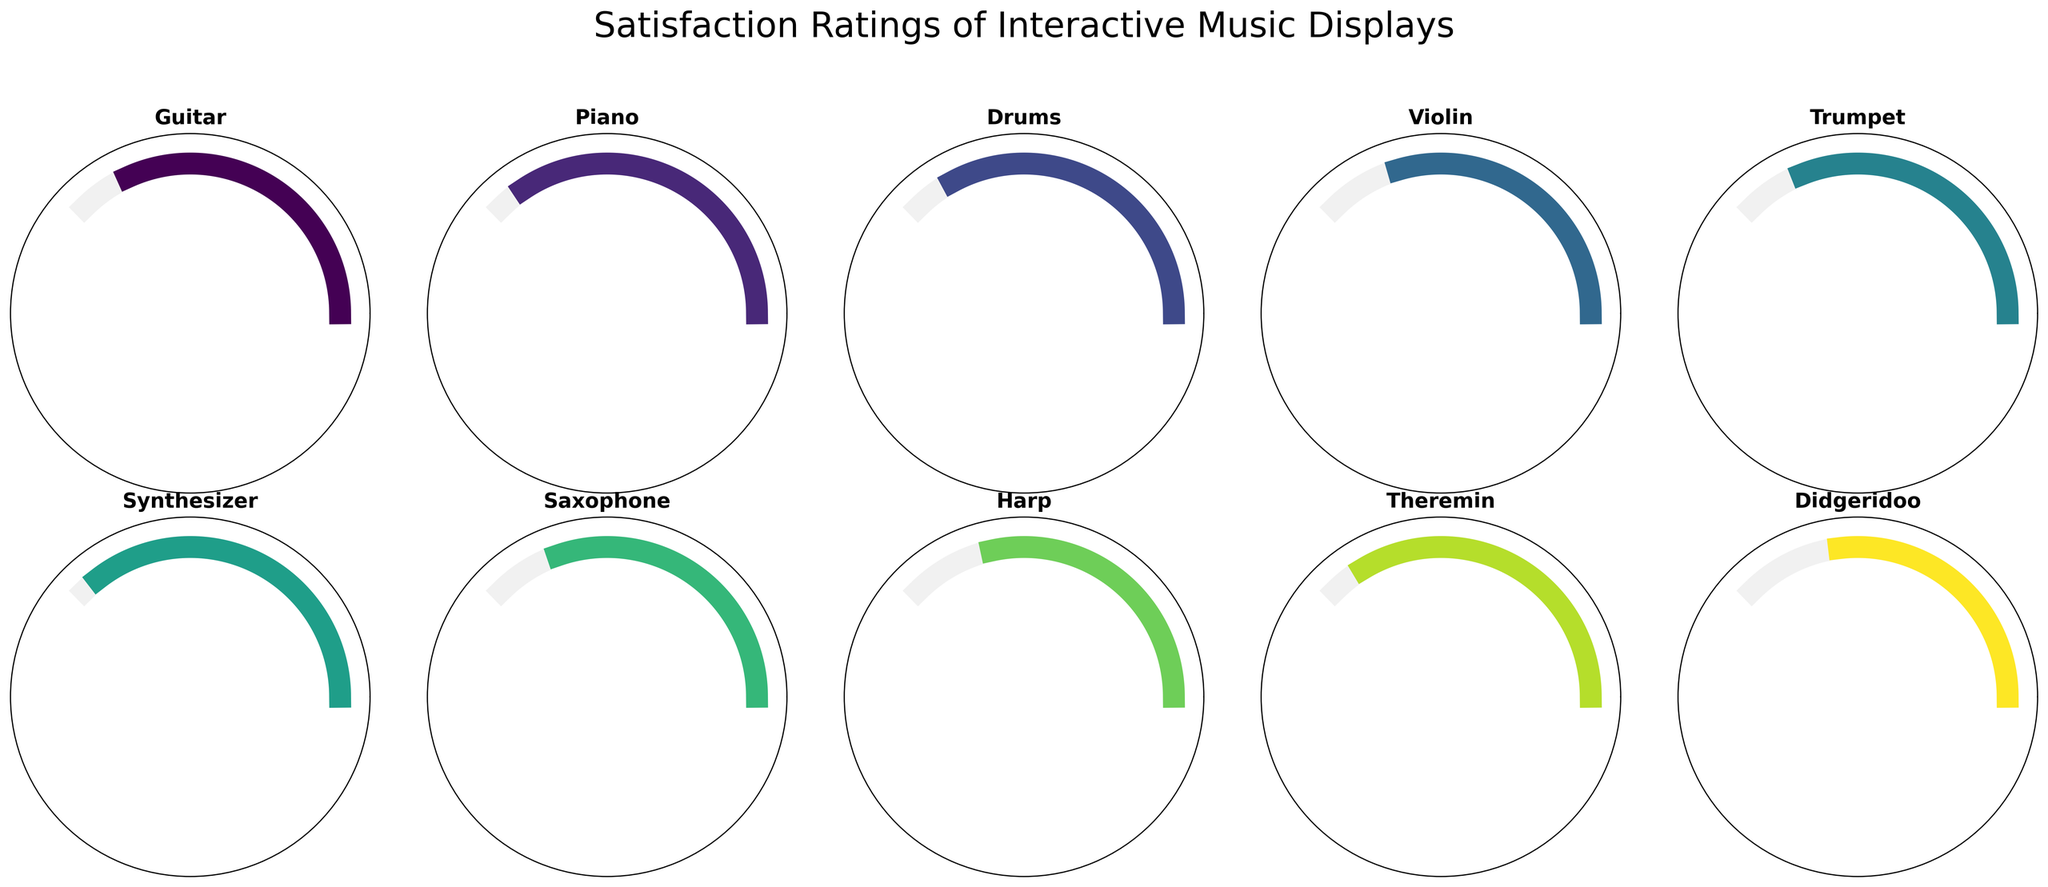How many instrument types are showcased in the figure? Count the number of individual instrument types visible in the Gauge Charts. There are 10 instrument types shown.
Answer: 10 What is the title of the figure? The title is typically displayed at the top of the figure. The title is "Satisfaction Ratings of Interactive Music Displays."
Answer: Satisfaction Ratings of Interactive Music Displays Which instrument has the highest satisfaction rating? Look for the instrument with the highest percentage shown in its gauge chart. The Synthesizer has the highest satisfaction rating at 95%.
Answer: Synthesizer What is the satisfaction rating for the Didgeridoo? Look at the gauge chart corresponding to the Didgeridoo and note the percentage displayed. The satisfaction rating for the Didgeridoo is 72%.
Answer: 72% Which instrument has a satisfaction rating of 85%? Find the gauge chart that shows an 85% rating. The Guitar has a satisfaction rating of 85%.
Answer: Guitar What is the average satisfaction rating of all the instruments? Add up the satisfaction ratings of all instruments and divide by the number of instruments. \((85 + 92 + 88 + 79 + 83 + 95 + 81 + 76 + 90 + 72) / 10 = 84.1\)
Answer: 84.1 Which instrument types have lower satisfaction ratings than the average rating? Calculate the average rating as previously (84.1) and compare each instrument's rating to this average. The Violin, Saxophone, Harp, and Didgeridoo have lower ratings than the average.
Answer: Violin, Saxophone, Harp, Didgeridoo What is the difference in satisfaction rating between the highest and lowest rated instruments? Subtract the rating of the lowest rated instrument from the highest rated instrument. The difference is \(95 - 72 = 23\).
Answer: 23 How many instruments have a rating greater than 90%? Count the number of gauge charts displaying a satisfaction rating above 90%. The Piano, Synthesizer, and Theremin have ratings greater than 90%.
Answer: 3 Which instrument has the closest satisfaction rating to 80%? Determine which instrument's rating is closest to 80% by comparing the absolute differences. The Trumpet has a rating of 83%, which is the closest to 80%.
Answer: Trumpet 